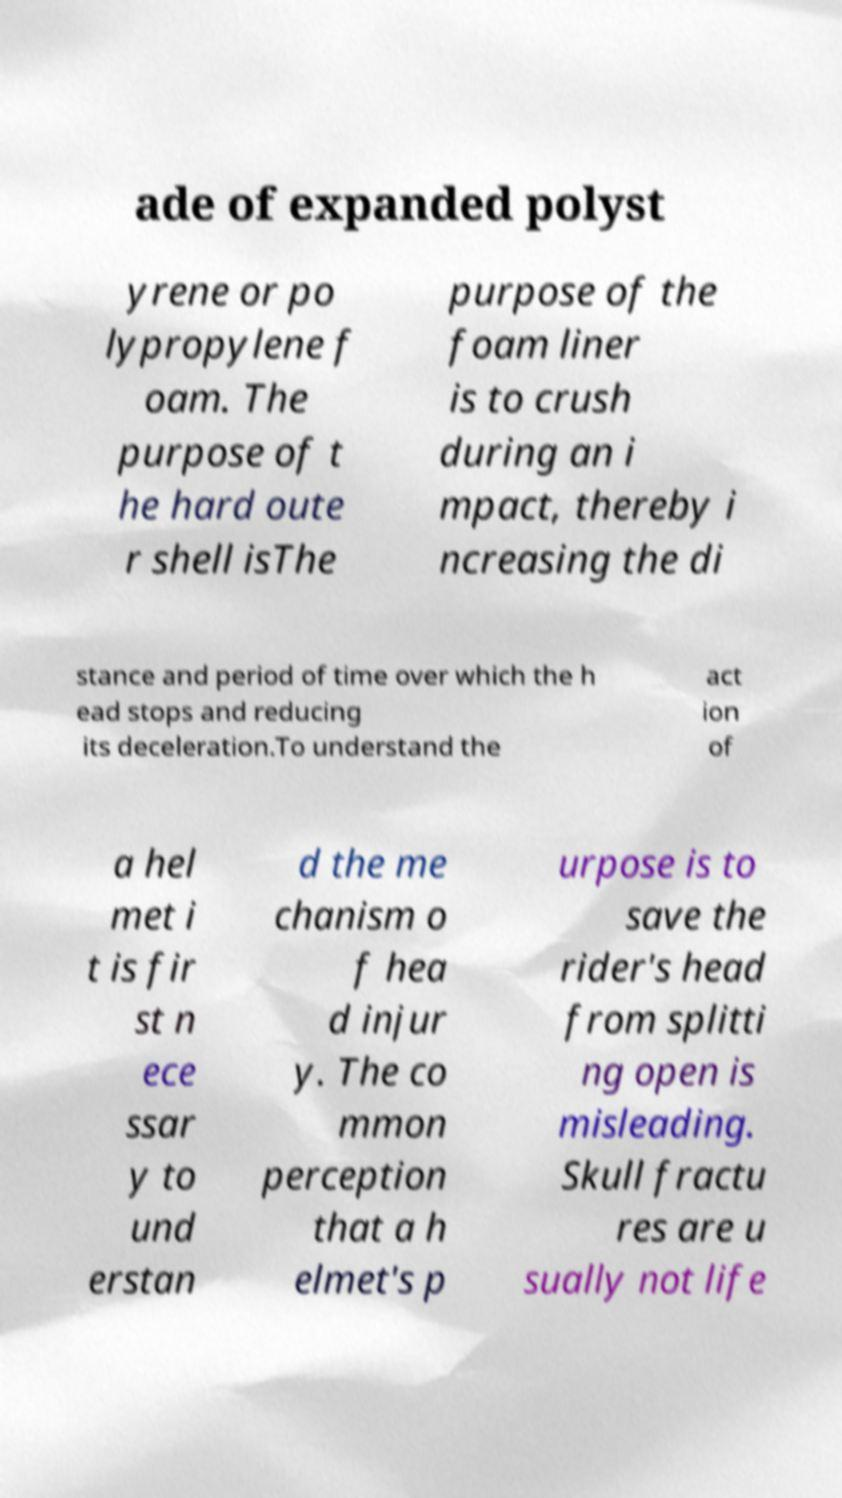What messages or text are displayed in this image? I need them in a readable, typed format. ade of expanded polyst yrene or po lypropylene f oam. The purpose of t he hard oute r shell isThe purpose of the foam liner is to crush during an i mpact, thereby i ncreasing the di stance and period of time over which the h ead stops and reducing its deceleration.To understand the act ion of a hel met i t is fir st n ece ssar y to und erstan d the me chanism o f hea d injur y. The co mmon perception that a h elmet's p urpose is to save the rider's head from splitti ng open is misleading. Skull fractu res are u sually not life 